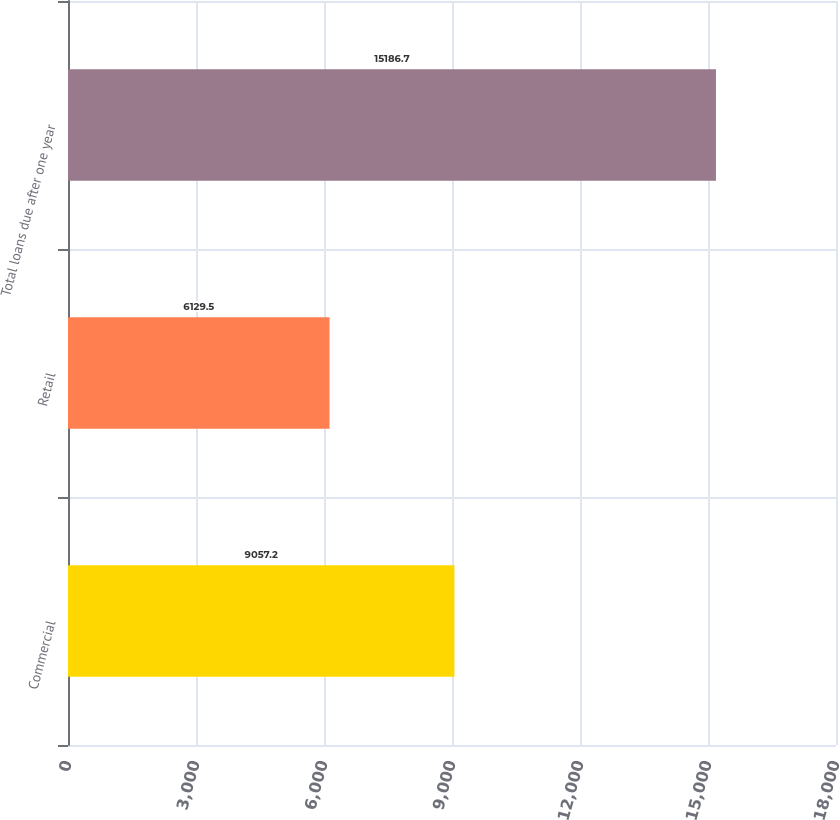Convert chart. <chart><loc_0><loc_0><loc_500><loc_500><bar_chart><fcel>Commercial<fcel>Retail<fcel>Total loans due after one year<nl><fcel>9057.2<fcel>6129.5<fcel>15186.7<nl></chart> 